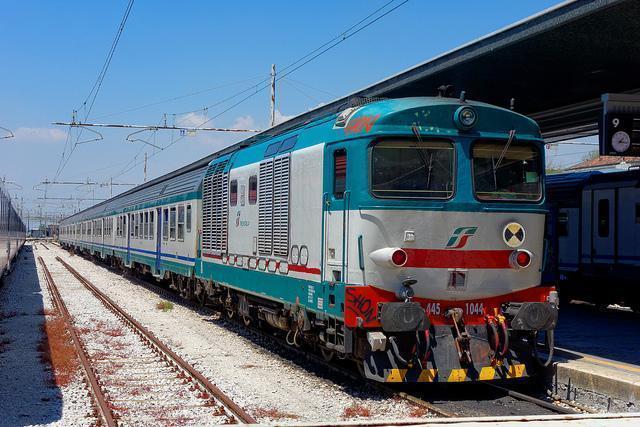What does this train carry?
Choose the correct response and explain in the format: 'Answer: answer
Rationale: rationale.'
Options: Cars, passengers, coal, livestock. Answer: passengers.
Rationale: As indicated by the windows on the train cars. the other options would look a lot different. 